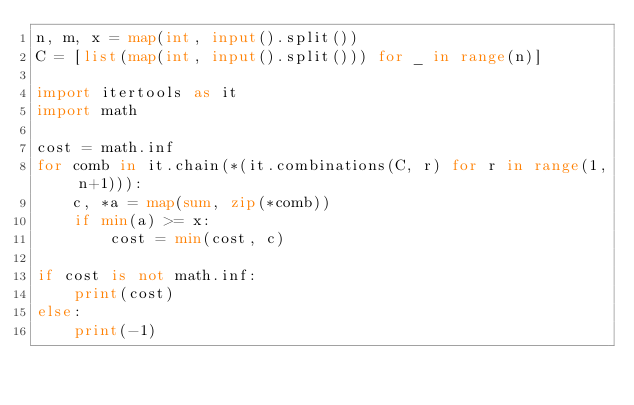<code> <loc_0><loc_0><loc_500><loc_500><_Python_>n, m, x = map(int, input().split())
C = [list(map(int, input().split())) for _ in range(n)]

import itertools as it
import math

cost = math.inf
for comb in it.chain(*(it.combinations(C, r) for r in range(1, n+1))):
    c, *a = map(sum, zip(*comb))
    if min(a) >= x:
        cost = min(cost, c)

if cost is not math.inf:
    print(cost)
else:
    print(-1)</code> 